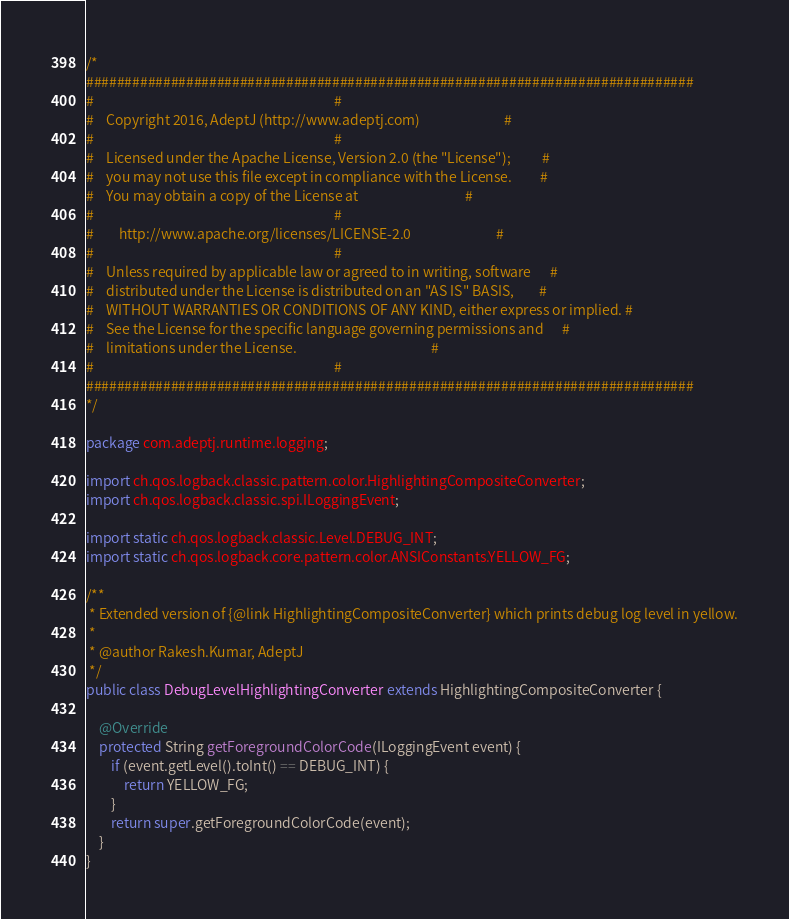<code> <loc_0><loc_0><loc_500><loc_500><_Java_>/*
###############################################################################
#                                                                             #
#    Copyright 2016, AdeptJ (http://www.adeptj.com)                           #
#                                                                             #
#    Licensed under the Apache License, Version 2.0 (the "License");          #
#    you may not use this file except in compliance with the License.         #
#    You may obtain a copy of the License at                                  #
#                                                                             #
#        http://www.apache.org/licenses/LICENSE-2.0                           #
#                                                                             #
#    Unless required by applicable law or agreed to in writing, software      #
#    distributed under the License is distributed on an "AS IS" BASIS,        #
#    WITHOUT WARRANTIES OR CONDITIONS OF ANY KIND, either express or implied. #
#    See the License for the specific language governing permissions and      #
#    limitations under the License.                                           #
#                                                                             #
###############################################################################
*/

package com.adeptj.runtime.logging;

import ch.qos.logback.classic.pattern.color.HighlightingCompositeConverter;
import ch.qos.logback.classic.spi.ILoggingEvent;

import static ch.qos.logback.classic.Level.DEBUG_INT;
import static ch.qos.logback.core.pattern.color.ANSIConstants.YELLOW_FG;

/**
 * Extended version of {@link HighlightingCompositeConverter} which prints debug log level in yellow.
 *
 * @author Rakesh.Kumar, AdeptJ
 */
public class DebugLevelHighlightingConverter extends HighlightingCompositeConverter {

    @Override
    protected String getForegroundColorCode(ILoggingEvent event) {
        if (event.getLevel().toInt() == DEBUG_INT) {
            return YELLOW_FG;
        }
        return super.getForegroundColorCode(event);
    }
}
</code> 